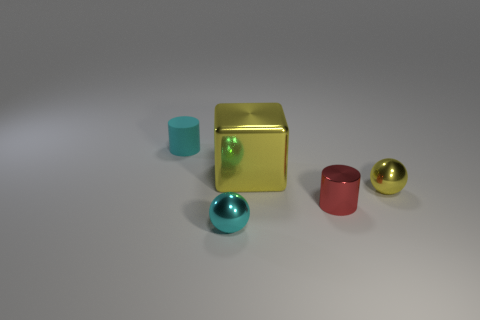Is there any other thing that is the same size as the yellow shiny cube?
Make the answer very short. No. There is a cyan object that is right of the cyan matte cylinder; are there any tiny cyan rubber cylinders on the left side of it?
Ensure brevity in your answer.  Yes. Does the tiny cyan thing in front of the large yellow shiny block have the same material as the tiny cyan cylinder?
Keep it short and to the point. No. How many other things are the same color as the metal cylinder?
Your answer should be compact. 0. There is a yellow thing that is behind the metal ball right of the tiny red cylinder; what size is it?
Your response must be concise. Large. Do the tiny cylinder that is in front of the tiny yellow thing and the small object behind the small yellow object have the same material?
Provide a short and direct response. No. Does the metal thing that is left of the yellow metal block have the same color as the rubber thing?
Ensure brevity in your answer.  Yes. How many small cyan rubber cylinders are left of the cyan metal thing?
Keep it short and to the point. 1. Do the tiny yellow object and the large cube that is on the left side of the tiny red metallic object have the same material?
Provide a succinct answer. Yes. What size is the cylinder that is made of the same material as the small yellow object?
Make the answer very short. Small. 